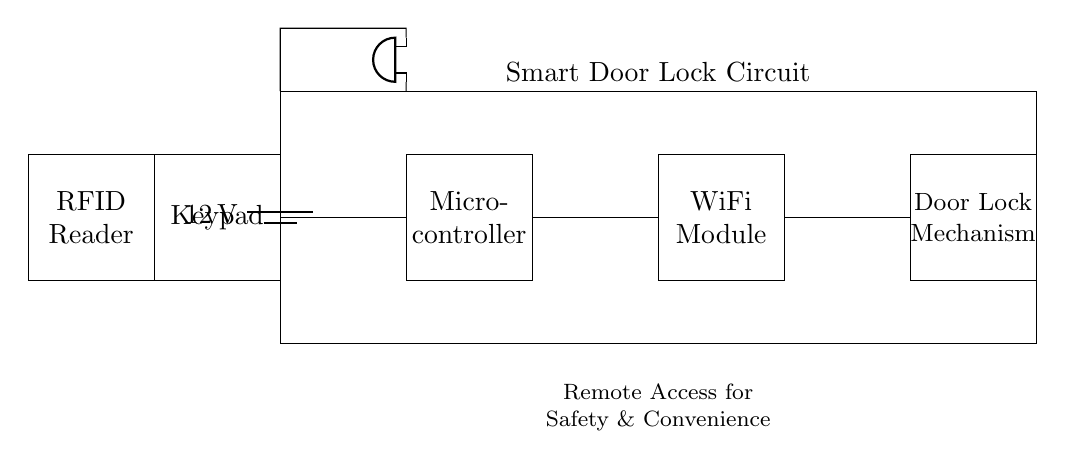What is the voltage of the power supply? The voltage of the power supply is labeled as 12V, which can be found in the circuit diagram at the battery symbol.
Answer: 12V What type of microcontroller is used in this circuit? The specific type of microcontroller is not provided in the diagram; however, it is represented by the rectangle labeled "Microcontroller."
Answer: Microcontroller How many main components are shown in the circuit? The main components include the power supply, microcontroller, WiFi module, door lock mechanism, keypad, RFID reader, and alarm. Counting these reveals a total of seven distinct components.
Answer: Seven What function does the WiFi module serve in this circuit? The WiFi module connects the microcontroller to a remote network, allowing access and control of the door lock from a distance, which is important for smart home integration.
Answer: Remote access Which component connects to the RFID reader? The circuit shows that the RFID reader connects to the microcontroller, allowing it to read RFID signals for locking and unlocking the door.
Answer: Microcontroller Where does the alarm get its power? The alarm is connected to the power supply that provides voltage through the circuit, indicated by the line connecting it back to the battery (power source) in the diagram.
Answer: Power supply What is the purpose of the keypad in this circuit? The keypad allows users to enter codes directly to control the door lock mechanism, providing a manual access option in addition to the remote capabilities offered by the WiFi module.
Answer: User input 